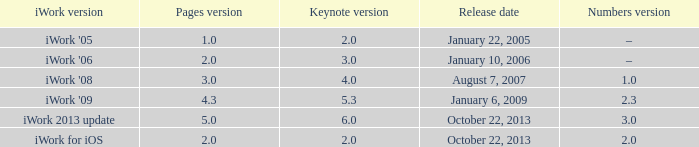What version of iWork was released on October 22, 2013 with a pages version greater than 2? Iwork 2013 update. 